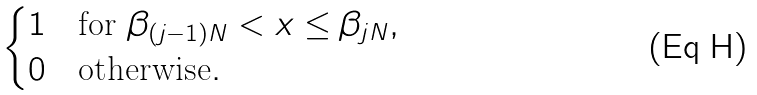<formula> <loc_0><loc_0><loc_500><loc_500>\begin{cases} 1 & \text {for $\beta_{(j-1)N}<x\leq \beta_{jN}$} , \\ 0 & \text {otherwise} . \end{cases}</formula> 